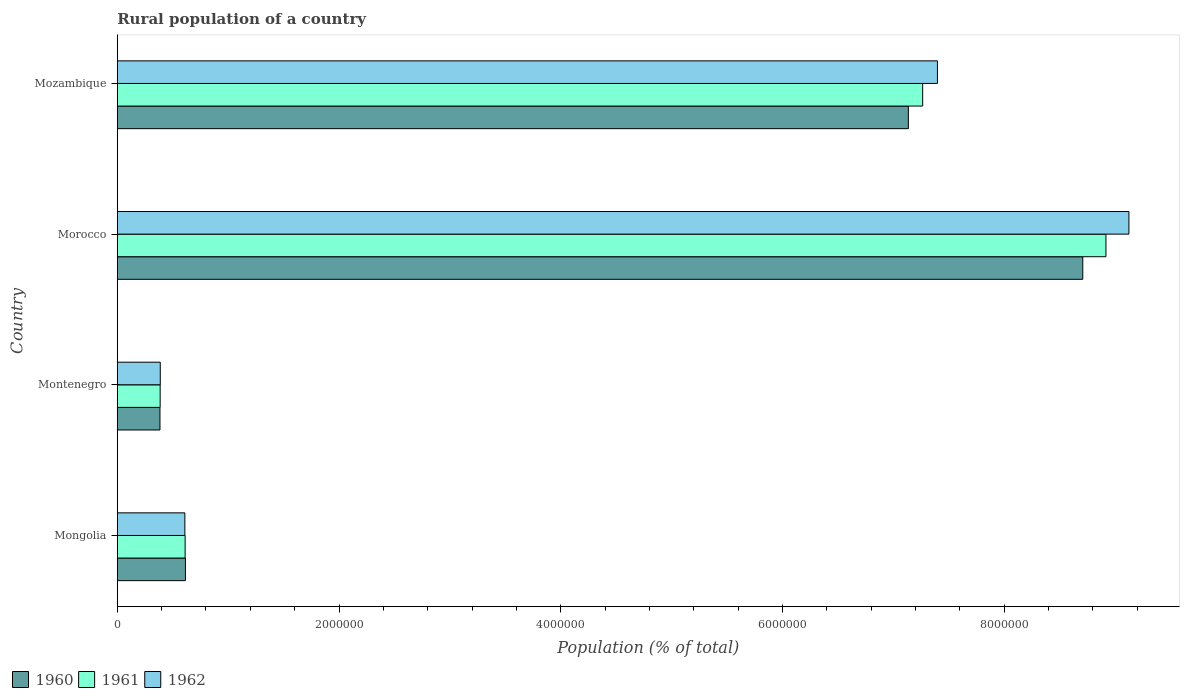Are the number of bars per tick equal to the number of legend labels?
Your response must be concise. Yes. Are the number of bars on each tick of the Y-axis equal?
Offer a terse response. Yes. How many bars are there on the 3rd tick from the top?
Keep it short and to the point. 3. What is the label of the 1st group of bars from the top?
Ensure brevity in your answer.  Mozambique. In how many cases, is the number of bars for a given country not equal to the number of legend labels?
Your answer should be very brief. 0. What is the rural population in 1961 in Montenegro?
Ensure brevity in your answer.  3.87e+05. Across all countries, what is the maximum rural population in 1961?
Provide a short and direct response. 8.92e+06. Across all countries, what is the minimum rural population in 1962?
Provide a short and direct response. 3.88e+05. In which country was the rural population in 1962 maximum?
Keep it short and to the point. Morocco. In which country was the rural population in 1962 minimum?
Provide a short and direct response. Montenegro. What is the total rural population in 1960 in the graph?
Give a very brief answer. 1.68e+07. What is the difference between the rural population in 1961 in Mongolia and that in Mozambique?
Your answer should be compact. -6.65e+06. What is the difference between the rural population in 1961 in Mongolia and the rural population in 1960 in Mozambique?
Make the answer very short. -6.52e+06. What is the average rural population in 1962 per country?
Ensure brevity in your answer.  4.38e+06. What is the difference between the rural population in 1962 and rural population in 1961 in Morocco?
Your response must be concise. 2.07e+05. What is the ratio of the rural population in 1960 in Morocco to that in Mozambique?
Make the answer very short. 1.22. What is the difference between the highest and the second highest rural population in 1961?
Offer a terse response. 1.65e+06. What is the difference between the highest and the lowest rural population in 1962?
Offer a very short reply. 8.74e+06. In how many countries, is the rural population in 1960 greater than the average rural population in 1960 taken over all countries?
Provide a succinct answer. 2. How many bars are there?
Keep it short and to the point. 12. How many legend labels are there?
Your answer should be very brief. 3. How are the legend labels stacked?
Offer a very short reply. Horizontal. What is the title of the graph?
Provide a short and direct response. Rural population of a country. What is the label or title of the X-axis?
Ensure brevity in your answer.  Population (% of total). What is the Population (% of total) of 1960 in Mongolia?
Make the answer very short. 6.15e+05. What is the Population (% of total) of 1961 in Mongolia?
Provide a succinct answer. 6.12e+05. What is the Population (% of total) in 1962 in Mongolia?
Make the answer very short. 6.10e+05. What is the Population (% of total) in 1960 in Montenegro?
Give a very brief answer. 3.85e+05. What is the Population (% of total) of 1961 in Montenegro?
Make the answer very short. 3.87e+05. What is the Population (% of total) of 1962 in Montenegro?
Keep it short and to the point. 3.88e+05. What is the Population (% of total) in 1960 in Morocco?
Provide a succinct answer. 8.71e+06. What is the Population (% of total) of 1961 in Morocco?
Give a very brief answer. 8.92e+06. What is the Population (% of total) in 1962 in Morocco?
Your response must be concise. 9.13e+06. What is the Population (% of total) in 1960 in Mozambique?
Your answer should be compact. 7.14e+06. What is the Population (% of total) in 1961 in Mozambique?
Provide a short and direct response. 7.27e+06. What is the Population (% of total) in 1962 in Mozambique?
Your answer should be very brief. 7.40e+06. Across all countries, what is the maximum Population (% of total) of 1960?
Offer a terse response. 8.71e+06. Across all countries, what is the maximum Population (% of total) of 1961?
Keep it short and to the point. 8.92e+06. Across all countries, what is the maximum Population (% of total) of 1962?
Your answer should be compact. 9.13e+06. Across all countries, what is the minimum Population (% of total) in 1960?
Keep it short and to the point. 3.85e+05. Across all countries, what is the minimum Population (% of total) in 1961?
Offer a terse response. 3.87e+05. Across all countries, what is the minimum Population (% of total) in 1962?
Ensure brevity in your answer.  3.88e+05. What is the total Population (% of total) in 1960 in the graph?
Provide a succinct answer. 1.68e+07. What is the total Population (% of total) of 1961 in the graph?
Ensure brevity in your answer.  1.72e+07. What is the total Population (% of total) of 1962 in the graph?
Your answer should be compact. 1.75e+07. What is the difference between the Population (% of total) in 1960 in Mongolia and that in Montenegro?
Your answer should be very brief. 2.29e+05. What is the difference between the Population (% of total) in 1961 in Mongolia and that in Montenegro?
Keep it short and to the point. 2.25e+05. What is the difference between the Population (% of total) in 1962 in Mongolia and that in Montenegro?
Your answer should be compact. 2.22e+05. What is the difference between the Population (% of total) in 1960 in Mongolia and that in Morocco?
Ensure brevity in your answer.  -8.09e+06. What is the difference between the Population (% of total) in 1961 in Mongolia and that in Morocco?
Provide a succinct answer. -8.31e+06. What is the difference between the Population (% of total) of 1962 in Mongolia and that in Morocco?
Offer a terse response. -8.52e+06. What is the difference between the Population (% of total) in 1960 in Mongolia and that in Mozambique?
Provide a short and direct response. -6.52e+06. What is the difference between the Population (% of total) in 1961 in Mongolia and that in Mozambique?
Your response must be concise. -6.65e+06. What is the difference between the Population (% of total) of 1962 in Mongolia and that in Mozambique?
Provide a short and direct response. -6.79e+06. What is the difference between the Population (% of total) of 1960 in Montenegro and that in Morocco?
Keep it short and to the point. -8.32e+06. What is the difference between the Population (% of total) in 1961 in Montenegro and that in Morocco?
Provide a short and direct response. -8.53e+06. What is the difference between the Population (% of total) of 1962 in Montenegro and that in Morocco?
Provide a short and direct response. -8.74e+06. What is the difference between the Population (% of total) of 1960 in Montenegro and that in Mozambique?
Offer a very short reply. -6.75e+06. What is the difference between the Population (% of total) in 1961 in Montenegro and that in Mozambique?
Make the answer very short. -6.88e+06. What is the difference between the Population (% of total) in 1962 in Montenegro and that in Mozambique?
Give a very brief answer. -7.01e+06. What is the difference between the Population (% of total) in 1960 in Morocco and that in Mozambique?
Provide a succinct answer. 1.57e+06. What is the difference between the Population (% of total) of 1961 in Morocco and that in Mozambique?
Make the answer very short. 1.65e+06. What is the difference between the Population (% of total) of 1962 in Morocco and that in Mozambique?
Give a very brief answer. 1.73e+06. What is the difference between the Population (% of total) in 1960 in Mongolia and the Population (% of total) in 1961 in Montenegro?
Provide a short and direct response. 2.28e+05. What is the difference between the Population (% of total) in 1960 in Mongolia and the Population (% of total) in 1962 in Montenegro?
Your response must be concise. 2.27e+05. What is the difference between the Population (% of total) in 1961 in Mongolia and the Population (% of total) in 1962 in Montenegro?
Keep it short and to the point. 2.24e+05. What is the difference between the Population (% of total) of 1960 in Mongolia and the Population (% of total) of 1961 in Morocco?
Provide a succinct answer. -8.30e+06. What is the difference between the Population (% of total) in 1960 in Mongolia and the Population (% of total) in 1962 in Morocco?
Your answer should be very brief. -8.51e+06. What is the difference between the Population (% of total) of 1961 in Mongolia and the Population (% of total) of 1962 in Morocco?
Keep it short and to the point. -8.51e+06. What is the difference between the Population (% of total) of 1960 in Mongolia and the Population (% of total) of 1961 in Mozambique?
Provide a short and direct response. -6.65e+06. What is the difference between the Population (% of total) of 1960 in Mongolia and the Population (% of total) of 1962 in Mozambique?
Offer a terse response. -6.78e+06. What is the difference between the Population (% of total) of 1961 in Mongolia and the Population (% of total) of 1962 in Mozambique?
Offer a terse response. -6.79e+06. What is the difference between the Population (% of total) in 1960 in Montenegro and the Population (% of total) in 1961 in Morocco?
Keep it short and to the point. -8.53e+06. What is the difference between the Population (% of total) in 1960 in Montenegro and the Population (% of total) in 1962 in Morocco?
Your response must be concise. -8.74e+06. What is the difference between the Population (% of total) in 1961 in Montenegro and the Population (% of total) in 1962 in Morocco?
Your response must be concise. -8.74e+06. What is the difference between the Population (% of total) of 1960 in Montenegro and the Population (% of total) of 1961 in Mozambique?
Ensure brevity in your answer.  -6.88e+06. What is the difference between the Population (% of total) of 1960 in Montenegro and the Population (% of total) of 1962 in Mozambique?
Your response must be concise. -7.01e+06. What is the difference between the Population (% of total) of 1961 in Montenegro and the Population (% of total) of 1962 in Mozambique?
Ensure brevity in your answer.  -7.01e+06. What is the difference between the Population (% of total) of 1960 in Morocco and the Population (% of total) of 1961 in Mozambique?
Provide a succinct answer. 1.44e+06. What is the difference between the Population (% of total) in 1960 in Morocco and the Population (% of total) in 1962 in Mozambique?
Provide a short and direct response. 1.31e+06. What is the difference between the Population (% of total) of 1961 in Morocco and the Population (% of total) of 1962 in Mozambique?
Provide a short and direct response. 1.52e+06. What is the average Population (% of total) in 1960 per country?
Make the answer very short. 4.21e+06. What is the average Population (% of total) in 1961 per country?
Your answer should be compact. 4.30e+06. What is the average Population (% of total) in 1962 per country?
Offer a very short reply. 4.38e+06. What is the difference between the Population (% of total) in 1960 and Population (% of total) in 1961 in Mongolia?
Give a very brief answer. 2521. What is the difference between the Population (% of total) of 1960 and Population (% of total) of 1962 in Mongolia?
Your response must be concise. 5069. What is the difference between the Population (% of total) of 1961 and Population (% of total) of 1962 in Mongolia?
Your answer should be very brief. 2548. What is the difference between the Population (% of total) in 1960 and Population (% of total) in 1961 in Montenegro?
Offer a terse response. -1569. What is the difference between the Population (% of total) of 1960 and Population (% of total) of 1962 in Montenegro?
Offer a terse response. -2612. What is the difference between the Population (% of total) of 1961 and Population (% of total) of 1962 in Montenegro?
Make the answer very short. -1043. What is the difference between the Population (% of total) in 1960 and Population (% of total) in 1961 in Morocco?
Your answer should be compact. -2.09e+05. What is the difference between the Population (% of total) of 1960 and Population (% of total) of 1962 in Morocco?
Provide a succinct answer. -4.16e+05. What is the difference between the Population (% of total) in 1961 and Population (% of total) in 1962 in Morocco?
Provide a succinct answer. -2.07e+05. What is the difference between the Population (% of total) in 1960 and Population (% of total) in 1961 in Mozambique?
Offer a very short reply. -1.29e+05. What is the difference between the Population (% of total) of 1960 and Population (% of total) of 1962 in Mozambique?
Your response must be concise. -2.62e+05. What is the difference between the Population (% of total) in 1961 and Population (% of total) in 1962 in Mozambique?
Ensure brevity in your answer.  -1.33e+05. What is the ratio of the Population (% of total) in 1960 in Mongolia to that in Montenegro?
Provide a succinct answer. 1.6. What is the ratio of the Population (% of total) of 1961 in Mongolia to that in Montenegro?
Offer a terse response. 1.58. What is the ratio of the Population (% of total) of 1962 in Mongolia to that in Montenegro?
Offer a very short reply. 1.57. What is the ratio of the Population (% of total) in 1960 in Mongolia to that in Morocco?
Offer a terse response. 0.07. What is the ratio of the Population (% of total) in 1961 in Mongolia to that in Morocco?
Keep it short and to the point. 0.07. What is the ratio of the Population (% of total) of 1962 in Mongolia to that in Morocco?
Your answer should be compact. 0.07. What is the ratio of the Population (% of total) in 1960 in Mongolia to that in Mozambique?
Keep it short and to the point. 0.09. What is the ratio of the Population (% of total) of 1961 in Mongolia to that in Mozambique?
Offer a terse response. 0.08. What is the ratio of the Population (% of total) of 1962 in Mongolia to that in Mozambique?
Make the answer very short. 0.08. What is the ratio of the Population (% of total) in 1960 in Montenegro to that in Morocco?
Give a very brief answer. 0.04. What is the ratio of the Population (% of total) in 1961 in Montenegro to that in Morocco?
Provide a succinct answer. 0.04. What is the ratio of the Population (% of total) of 1962 in Montenegro to that in Morocco?
Offer a very short reply. 0.04. What is the ratio of the Population (% of total) in 1960 in Montenegro to that in Mozambique?
Give a very brief answer. 0.05. What is the ratio of the Population (% of total) of 1961 in Montenegro to that in Mozambique?
Keep it short and to the point. 0.05. What is the ratio of the Population (% of total) of 1962 in Montenegro to that in Mozambique?
Make the answer very short. 0.05. What is the ratio of the Population (% of total) of 1960 in Morocco to that in Mozambique?
Ensure brevity in your answer.  1.22. What is the ratio of the Population (% of total) of 1961 in Morocco to that in Mozambique?
Make the answer very short. 1.23. What is the ratio of the Population (% of total) in 1962 in Morocco to that in Mozambique?
Keep it short and to the point. 1.23. What is the difference between the highest and the second highest Population (% of total) of 1960?
Offer a terse response. 1.57e+06. What is the difference between the highest and the second highest Population (% of total) in 1961?
Make the answer very short. 1.65e+06. What is the difference between the highest and the second highest Population (% of total) of 1962?
Provide a succinct answer. 1.73e+06. What is the difference between the highest and the lowest Population (% of total) in 1960?
Provide a short and direct response. 8.32e+06. What is the difference between the highest and the lowest Population (% of total) of 1961?
Ensure brevity in your answer.  8.53e+06. What is the difference between the highest and the lowest Population (% of total) in 1962?
Ensure brevity in your answer.  8.74e+06. 